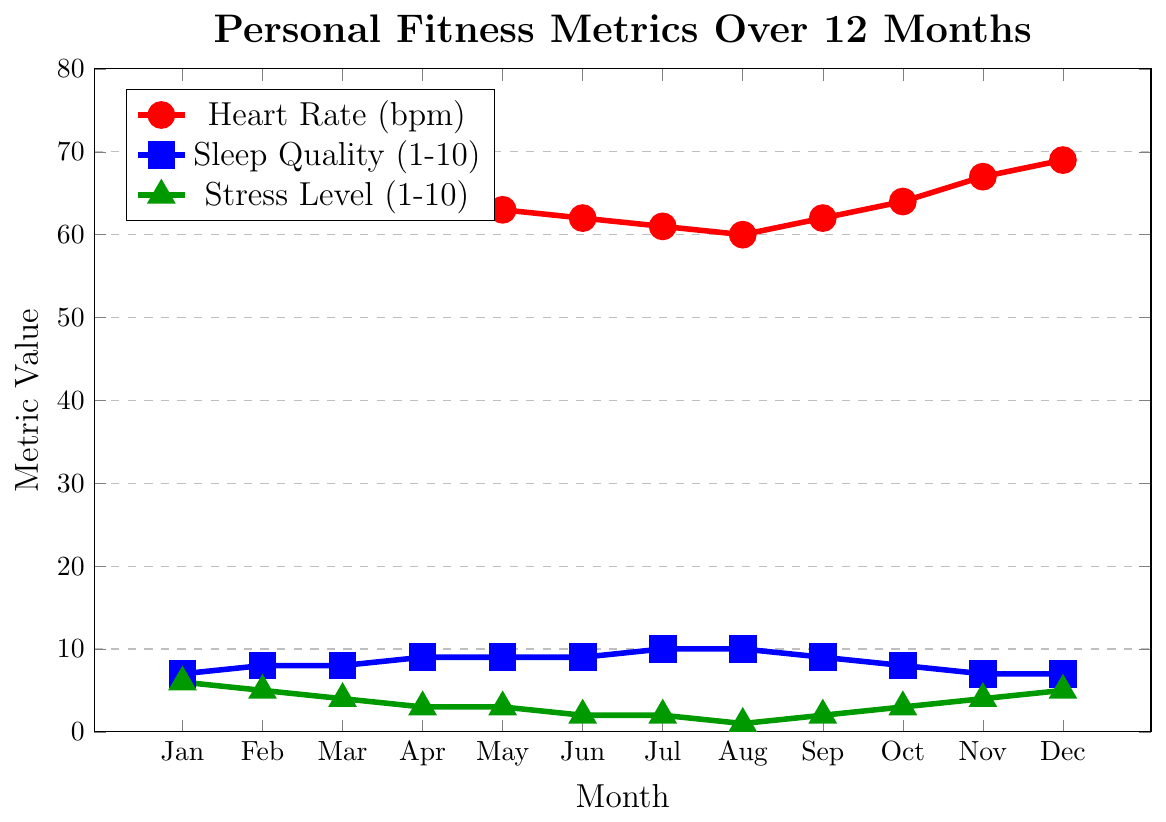What month had the lowest heart rate and what was the value? The graph shows heart rates for each month. By identifying the lowest point on the red line, it's in August with a heart rate of 60 bpm.
Answer: August, 60 bpm Which month experienced the highest sleep quality and what was the value? The sleep quality is represented by the blue line. The highest point on the graph occurs in July and August with a value of 10.
Answer: July and August, 10 How did the stress level change from January to December? Visually follow the green line from January to December. The stress level decreased from 6 in January to 1 in August, then slightly increased up to 5 by December.
Answer: Decreased, then slightly increased What relationship do you observe between stress levels and sleep quality over the 12 months? Sleep quality generally increases as stress levels decrease. The mirrored trends where sleep quality peaks correspond to the lowest stress levels (July, August).
Answer: Inverse relationship Calculate the average heart rate over the 12 months. Sum up all the heart rate values (72+70+68+65+63+62+61+60+62+64+67+69 = 783) and divide by 12. (783/12 = 65.25)
Answer: 65.25 bpm Compare the heart rate in May with the one in November. Which is higher? The red line shows the heart rate in May is 63 bpm and in November is 67 bpm.
Answer: November During which months is the stress level below 3? Identify the green line points below the value of 3: June, July, August, September.
Answer: June, July, August, September What general trend do you observe in heart rate from January to August? The red line shows a consistent downward trend in heart rate values from January to August.
Answer: Decreasing trend What is the difference in heart rate between February and October? The red line shows the heart rate in February is 70 bpm and in October is 64 bpm. The difference is 70 - 64 = 6 bpm.
Answer: 6 bpm How many months had a sleep quality of 9 or higher? The blue line shows sleep quality is 9 in April, May, June, September and 10 in July, August. This results in a total of 6 months.
Answer: 6 months 